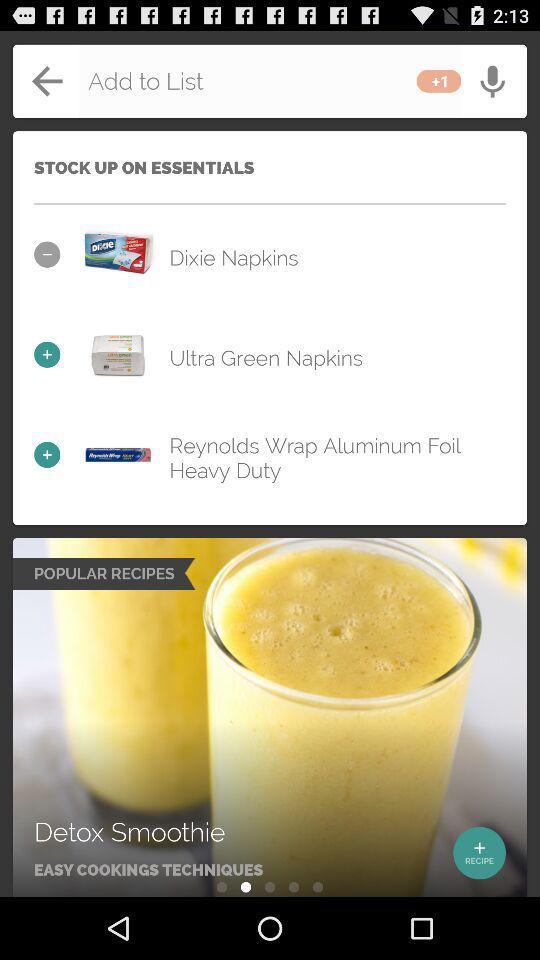What item is present in "POPULAR RECIPES"? The item present in "POPULAR RECIPES" is "Detox Smoothie". 